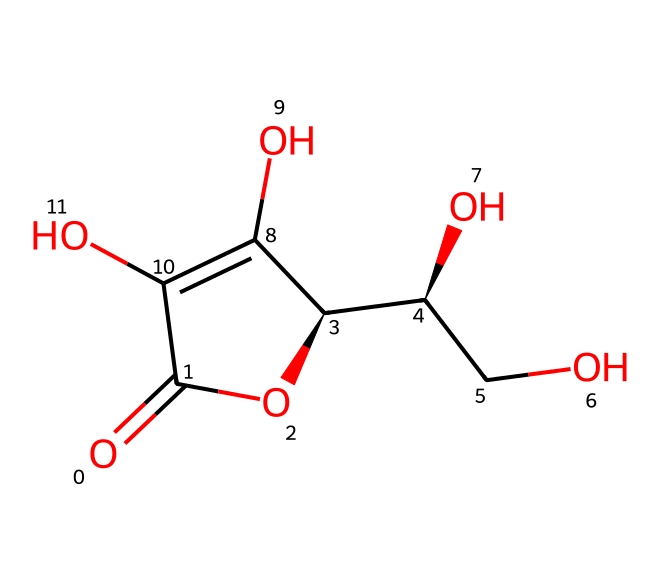How many carbon atoms are in vitamin C? The provided SMILES indicates the presence of six total carbon atoms derived from counting the 'C' symbols in the representation.
Answer: six What is the molecular formula for vitamin C? By analyzing the SMILES structure, we can derive that vitamin C has the molecular formula C6H8O6, indicating six carbon atoms, eight hydrogen atoms, and six oxygen atoms.
Answer: C6H8O6 How many hydroxyl (-OH) groups are present in vitamin C? Upon examining the chemical structure, there are four hydroxyl groups indicated by the 'O' atoms connected to 'C' in the structure, which infers the presence of four -OH groups attached.
Answer: four What type of agent is vitamin C commonly known as in chemistry? Vitamin C is widely recognized as a reducing agent, which is evident from its ability to donate electrons in redox reactions due to the presence of its multiple hydroxyl and carbonyl groups.
Answer: reducing agent How many double bonds are in the structure of vitamin C? The SMILES structure represents two double bonds, which are identifiable from the occurrences of '=' symbols, indicating a total of two double bonds within the molecular structure.
Answer: two What is the significance of the chirality in vitamin C? The presence of chiral centers in the structure is notable, as it leads to two enantiomers; specifically, vitamin C exists in both the D and L forms, with specific biological activity related to the configuration.
Answer: chirality What is the primary biological function of vitamin C? Vitamin C primarily functions as an antioxidant in biological systems, protecting cells from oxidative damage and playing a crucial role in collagen synthesis.
Answer: antioxidant 